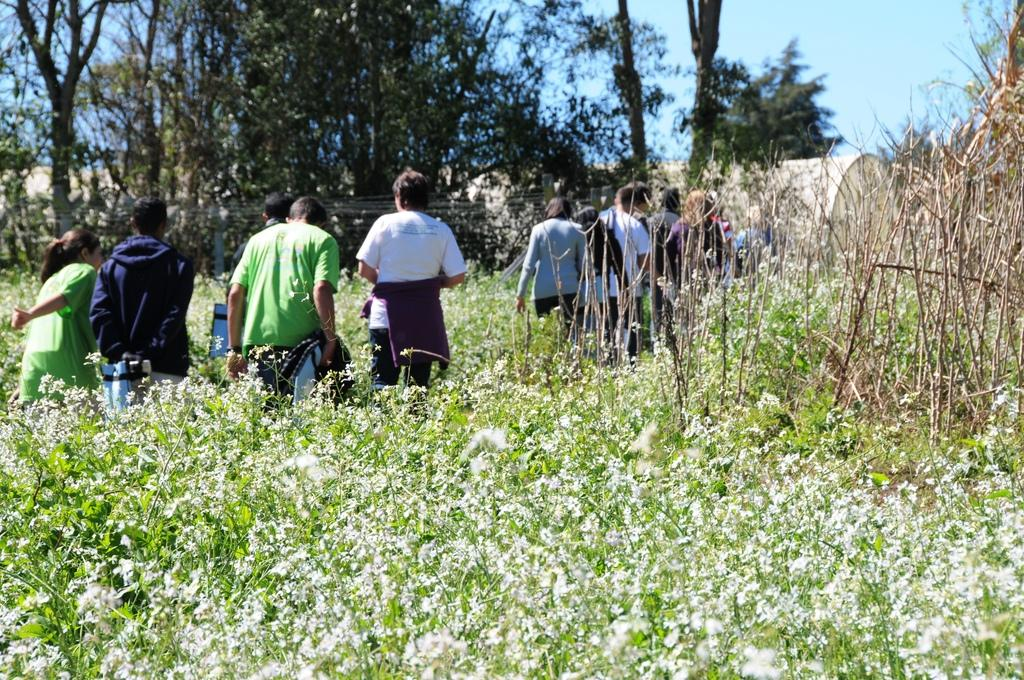Who or what can be seen in the image? There are people in the image. What type of vegetation is present in the image? There are plants, flowers, and grass in the image. What can be seen in the background of the image? There are trees and the sky visible in the background of the image. What type of toy can be seen in the image? There is no toy present in the image. What kind of nut is being used as a seat in the image? There is no nut being used as a seat in the image. 